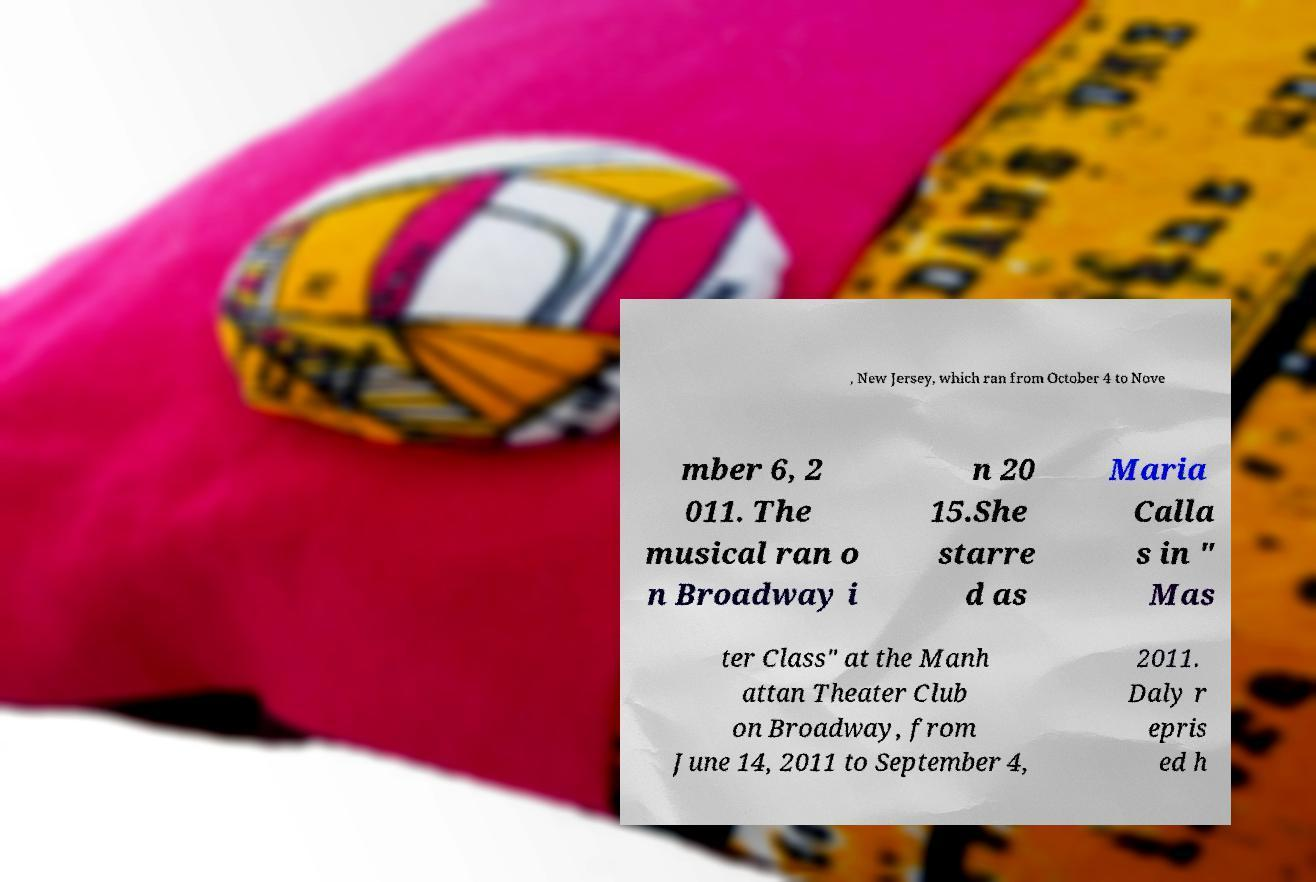Can you read and provide the text displayed in the image?This photo seems to have some interesting text. Can you extract and type it out for me? , New Jersey, which ran from October 4 to Nove mber 6, 2 011. The musical ran o n Broadway i n 20 15.She starre d as Maria Calla s in " Mas ter Class" at the Manh attan Theater Club on Broadway, from June 14, 2011 to September 4, 2011. Daly r epris ed h 